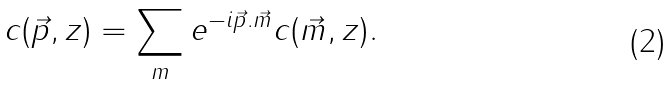Convert formula to latex. <formula><loc_0><loc_0><loc_500><loc_500>c ( \vec { p } , z ) = \sum _ { m } e ^ { - i \vec { p } . \vec { m } } c ( \vec { m } , z ) .</formula> 